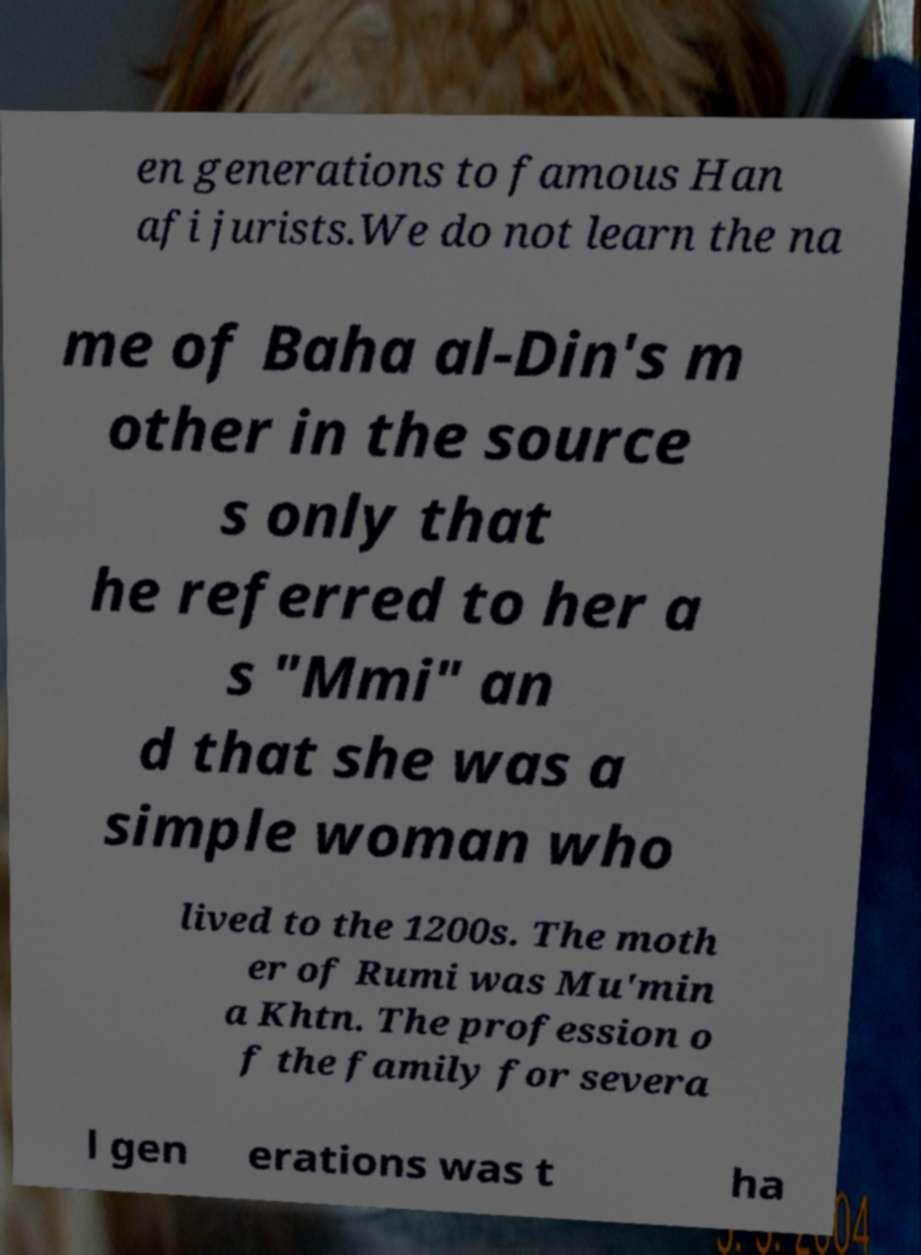Please read and relay the text visible in this image. What does it say? en generations to famous Han afi jurists.We do not learn the na me of Baha al-Din's m other in the source s only that he referred to her a s "Mmi" an d that she was a simple woman who lived to the 1200s. The moth er of Rumi was Mu'min a Khtn. The profession o f the family for severa l gen erations was t ha 